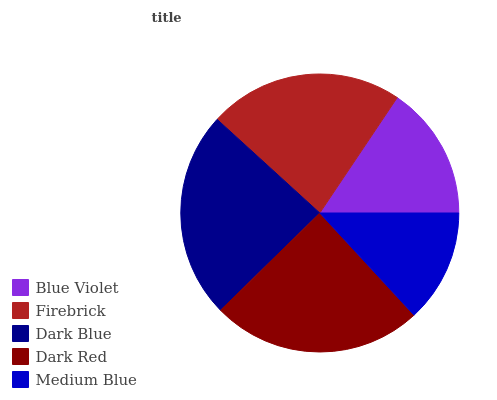Is Medium Blue the minimum?
Answer yes or no. Yes. Is Dark Red the maximum?
Answer yes or no. Yes. Is Firebrick the minimum?
Answer yes or no. No. Is Firebrick the maximum?
Answer yes or no. No. Is Firebrick greater than Blue Violet?
Answer yes or no. Yes. Is Blue Violet less than Firebrick?
Answer yes or no. Yes. Is Blue Violet greater than Firebrick?
Answer yes or no. No. Is Firebrick less than Blue Violet?
Answer yes or no. No. Is Firebrick the high median?
Answer yes or no. Yes. Is Firebrick the low median?
Answer yes or no. Yes. Is Medium Blue the high median?
Answer yes or no. No. Is Dark Blue the low median?
Answer yes or no. No. 